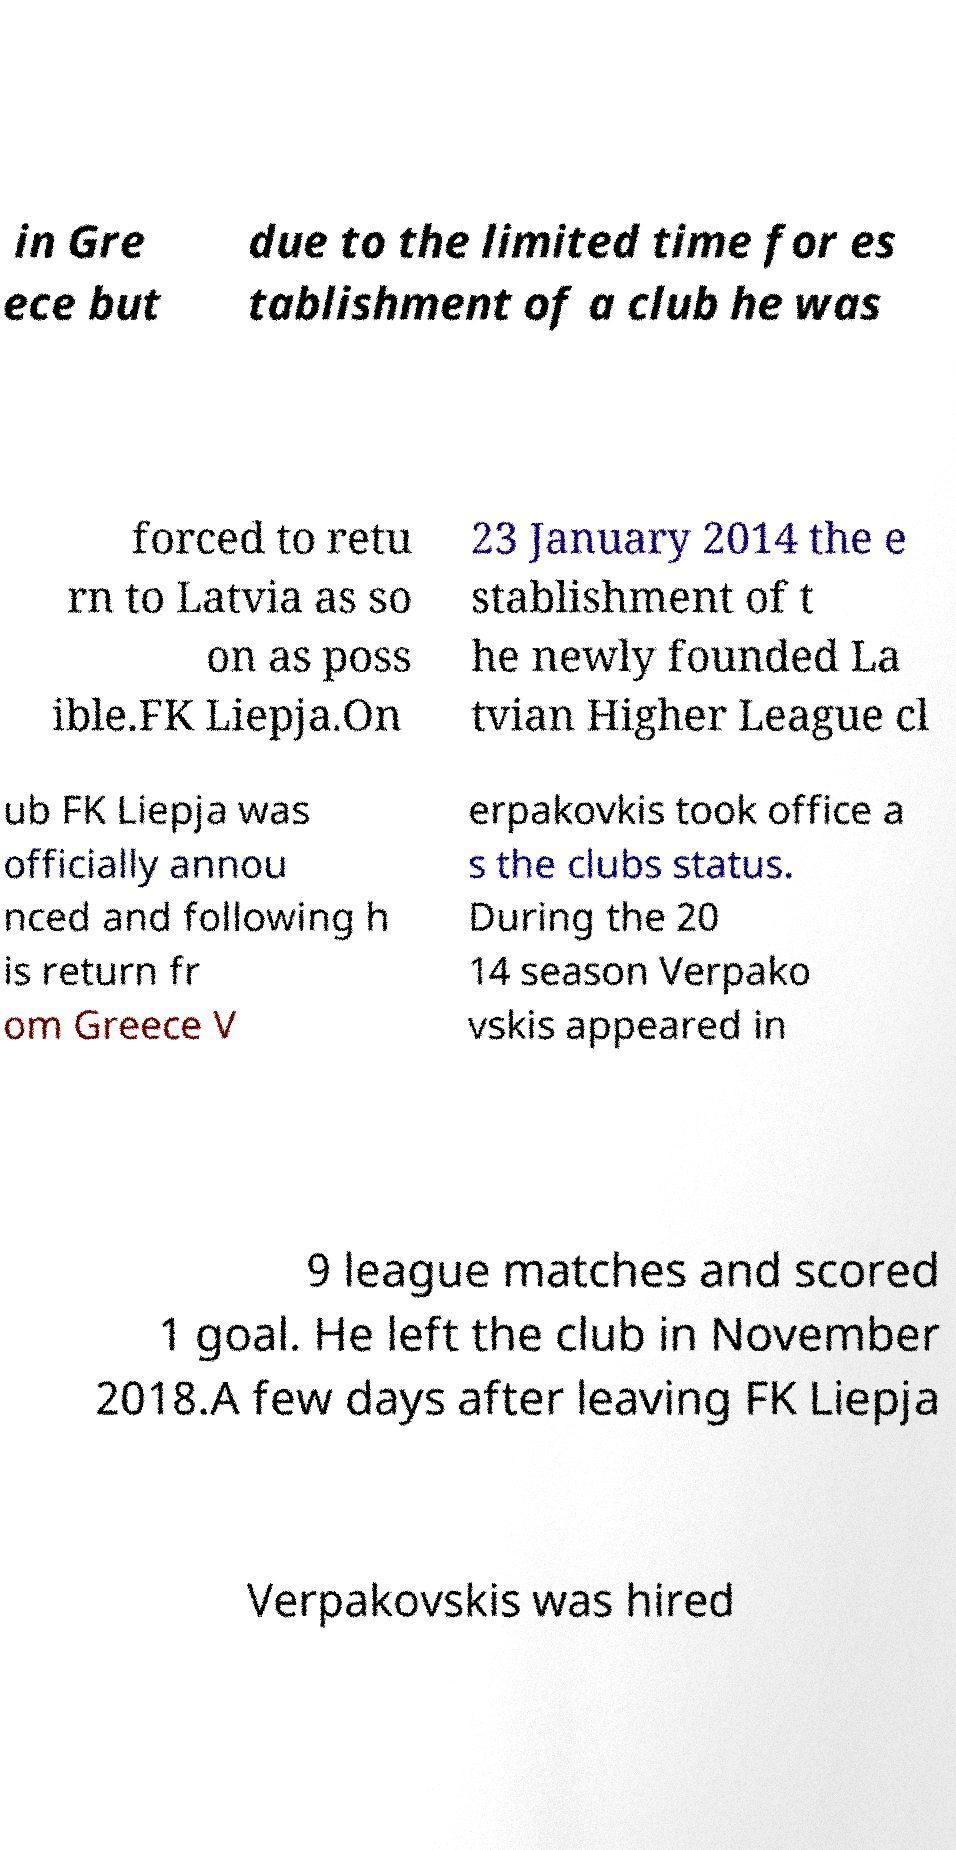What messages or text are displayed in this image? I need them in a readable, typed format. in Gre ece but due to the limited time for es tablishment of a club he was forced to retu rn to Latvia as so on as poss ible.FK Liepja.On 23 January 2014 the e stablishment of t he newly founded La tvian Higher League cl ub FK Liepja was officially annou nced and following h is return fr om Greece V erpakovkis took office a s the clubs status. During the 20 14 season Verpako vskis appeared in 9 league matches and scored 1 goal. He left the club in November 2018.A few days after leaving FK Liepja Verpakovskis was hired 